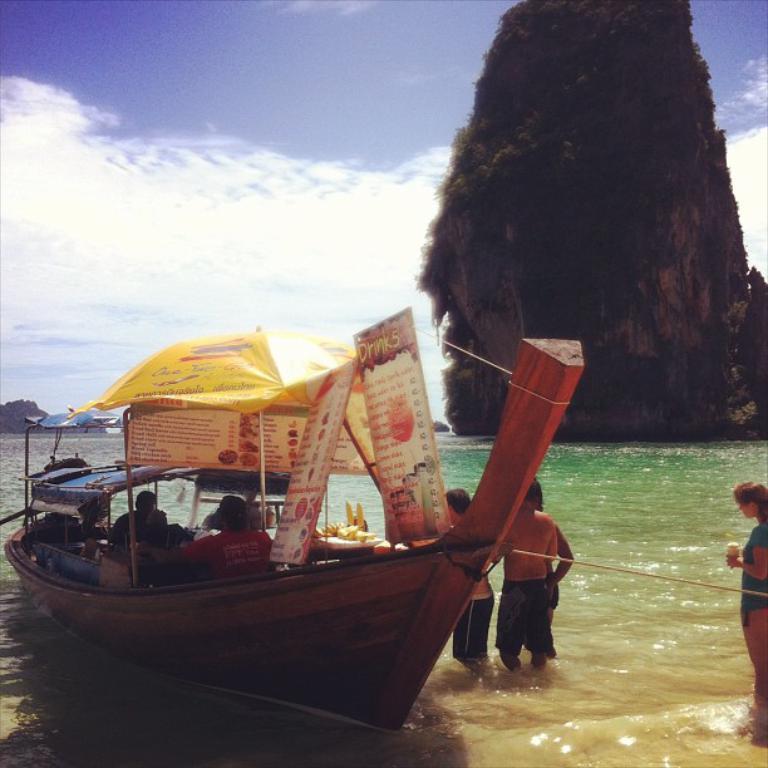Could you give a brief overview of what you see in this image? In this picture we can see a boat on the water with some persons, banners, umbrella on it, mountains and in the background we can see the sky with clouds. 